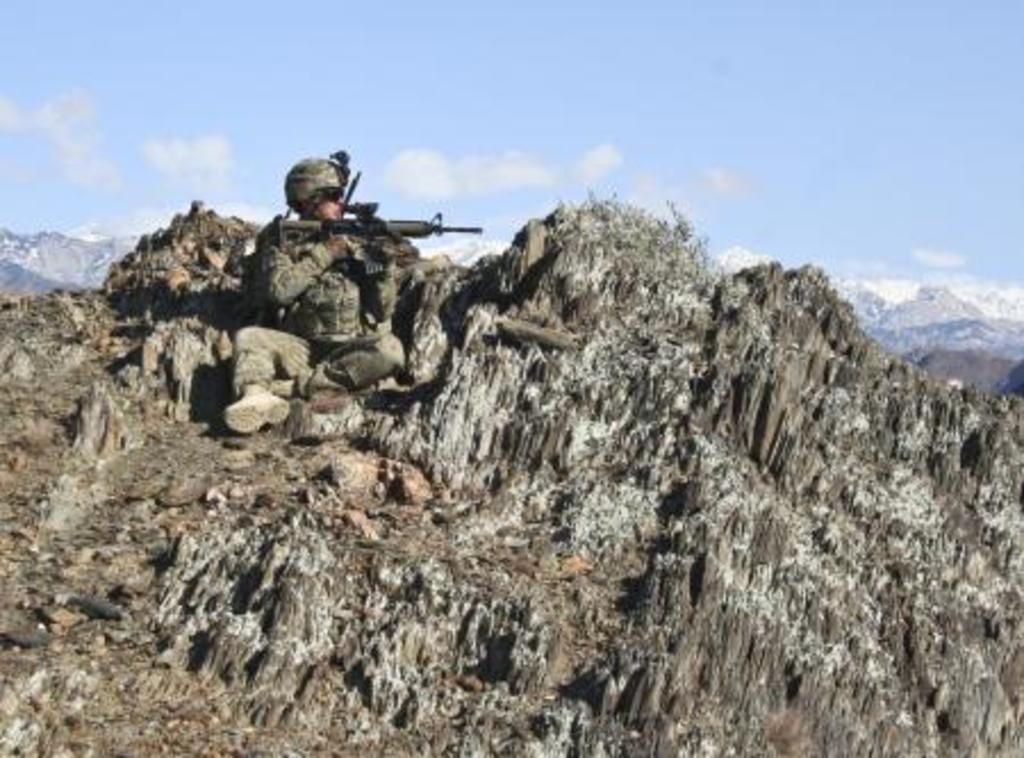Describe this image in one or two sentences. In this image we can see a person sitting the mountain and holding a gun. There are many mountains in the image. We can see the clouds in the sky. 